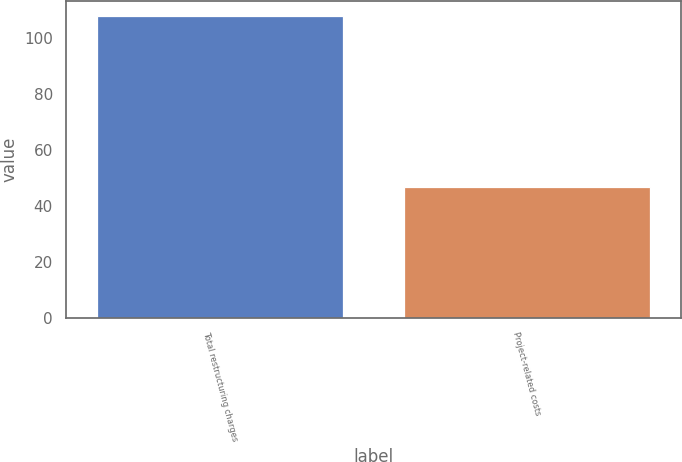Convert chart. <chart><loc_0><loc_0><loc_500><loc_500><bar_chart><fcel>Total restructuring charges<fcel>Project-related costs<nl><fcel>107.8<fcel>46.9<nl></chart> 